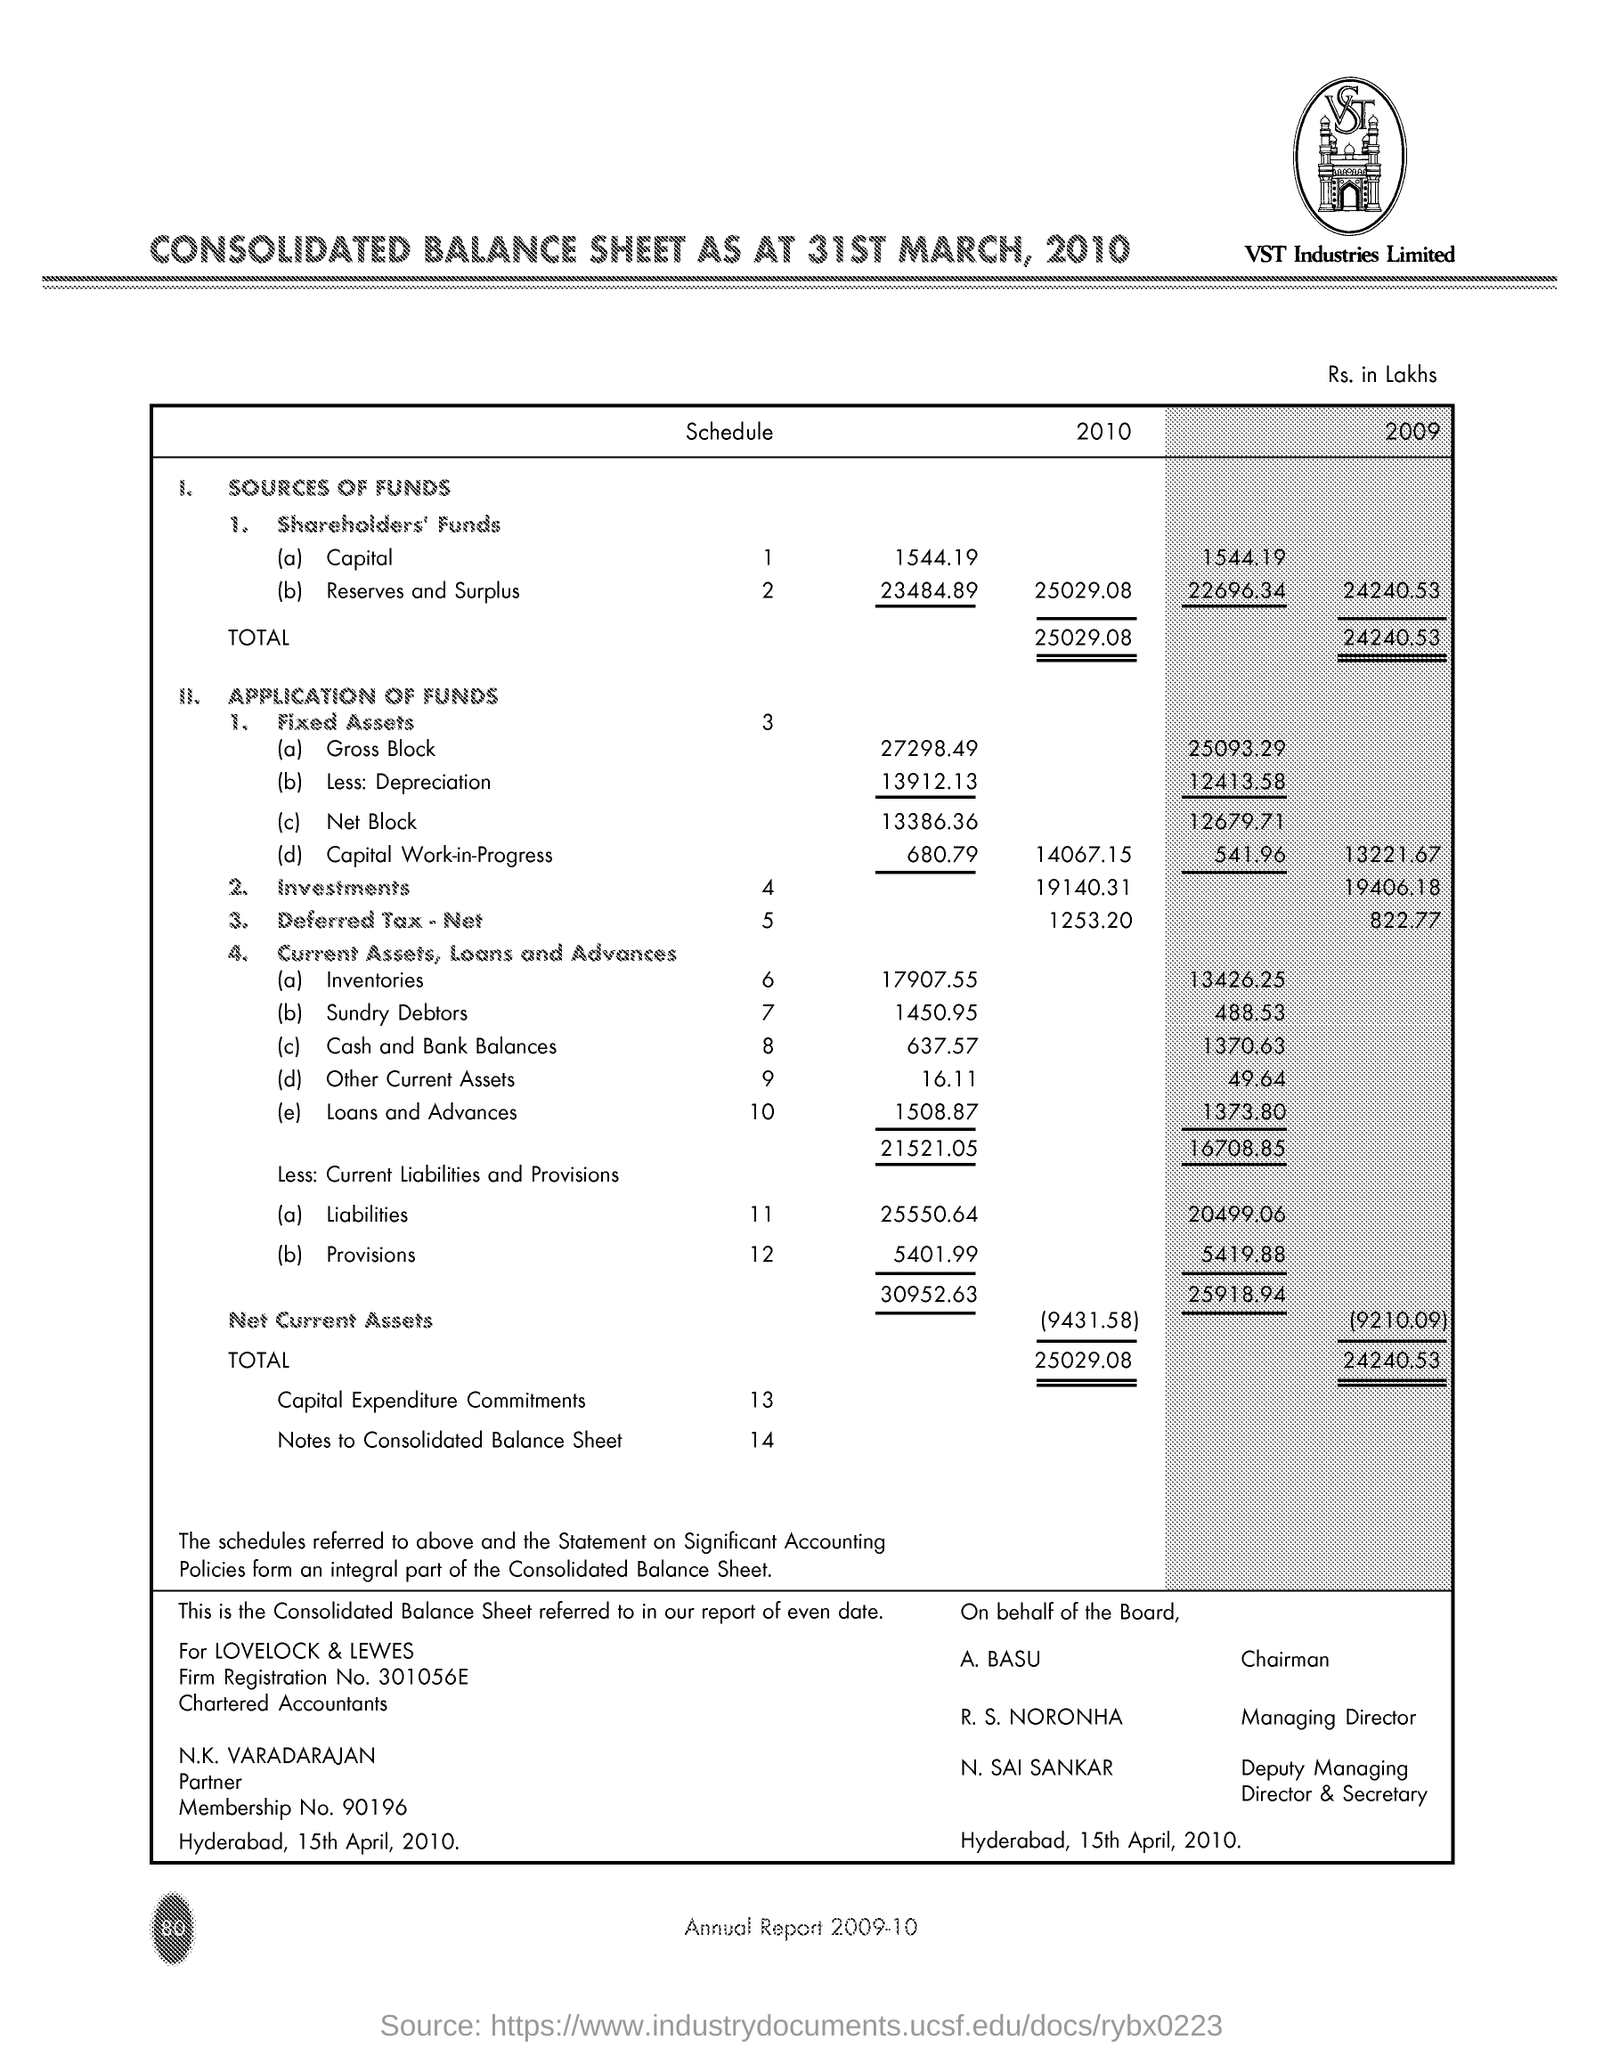What is mentioned in the Letter Head ?
Your response must be concise. CONSOLIDATED BALANCE SHEET AS AT 31ST MARCH, 2010. What is the Schedule number for  Reserves and  Surplus ?
Offer a very short reply. 2. Who is the Chairman ?
Give a very brief answer. A. BASU. What is the Firm Registration Number ?
Your response must be concise. 301056E. What is the Membership Number ?
Offer a very short reply. 90196. Who is the Managing Director ?
Your answer should be very brief. R. S. NORONHA. What is the Investments Schedule Number ?
Provide a succinct answer. 4. Who is the Deputy Managing Director & Secretary ?
Give a very brief answer. N. SAI SANKAR. 